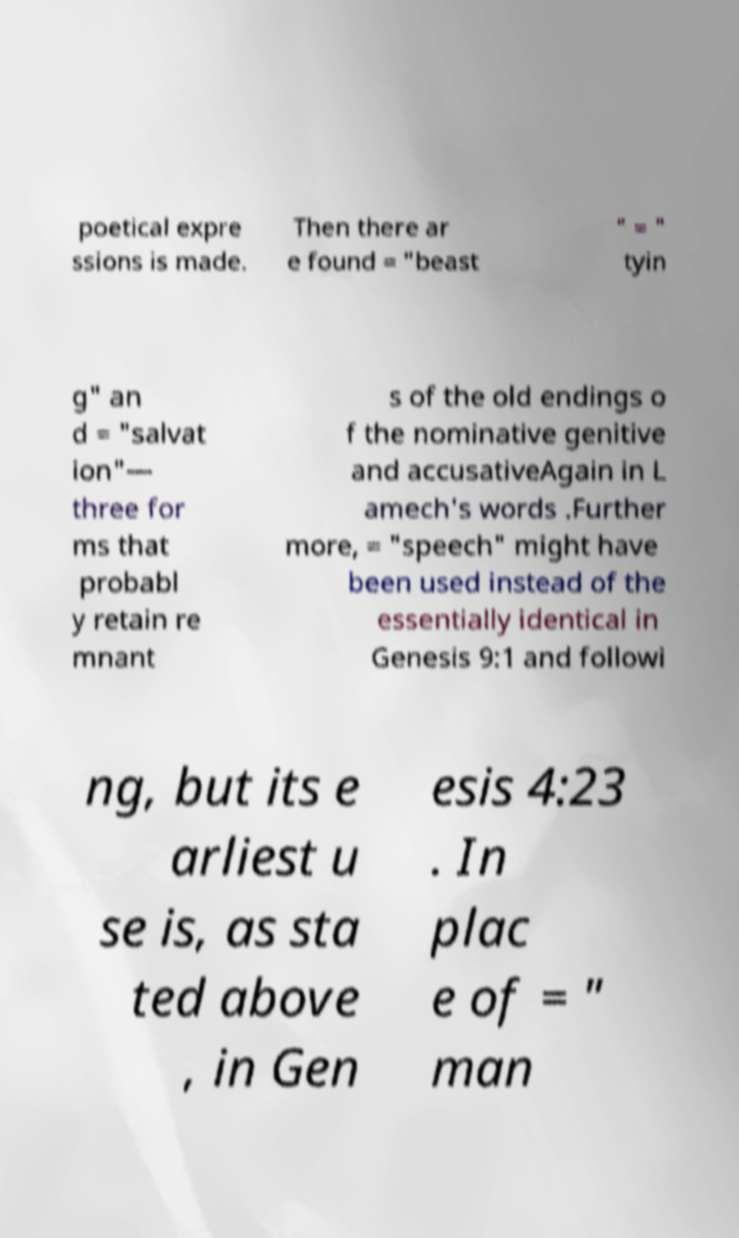There's text embedded in this image that I need extracted. Can you transcribe it verbatim? poetical expre ssions is made. Then there ar e found = "beast " = " tyin g" an d = "salvat ion"— three for ms that probabl y retain re mnant s of the old endings o f the nominative genitive and accusativeAgain in L amech's words .Further more, = "speech" might have been used instead of the essentially identical in Genesis 9:1 and followi ng, but its e arliest u se is, as sta ted above , in Gen esis 4:23 . In plac e of = " man 